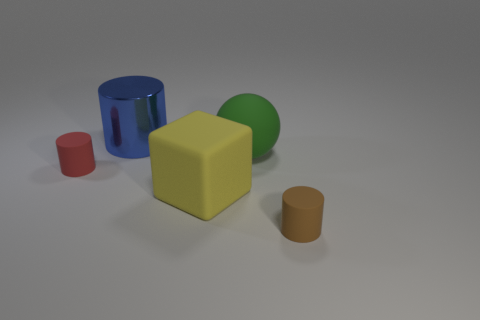Add 2 large spheres. How many objects exist? 7 Subtract all cubes. How many objects are left? 4 Subtract 0 blue cubes. How many objects are left? 5 Subtract all brown metallic objects. Subtract all blue objects. How many objects are left? 4 Add 3 matte things. How many matte things are left? 7 Add 5 big purple cubes. How many big purple cubes exist? 5 